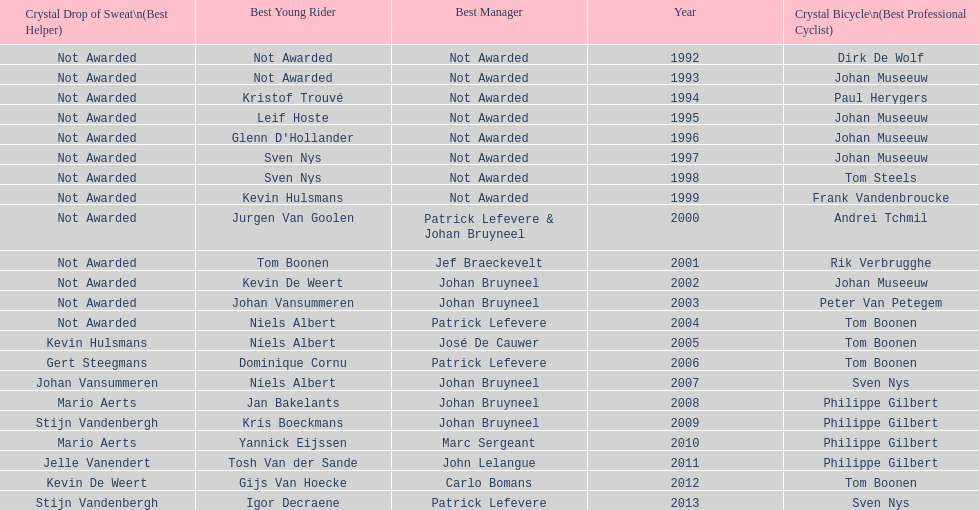What is the total number of times johan bryneel's name appears on all of these lists? 6. 